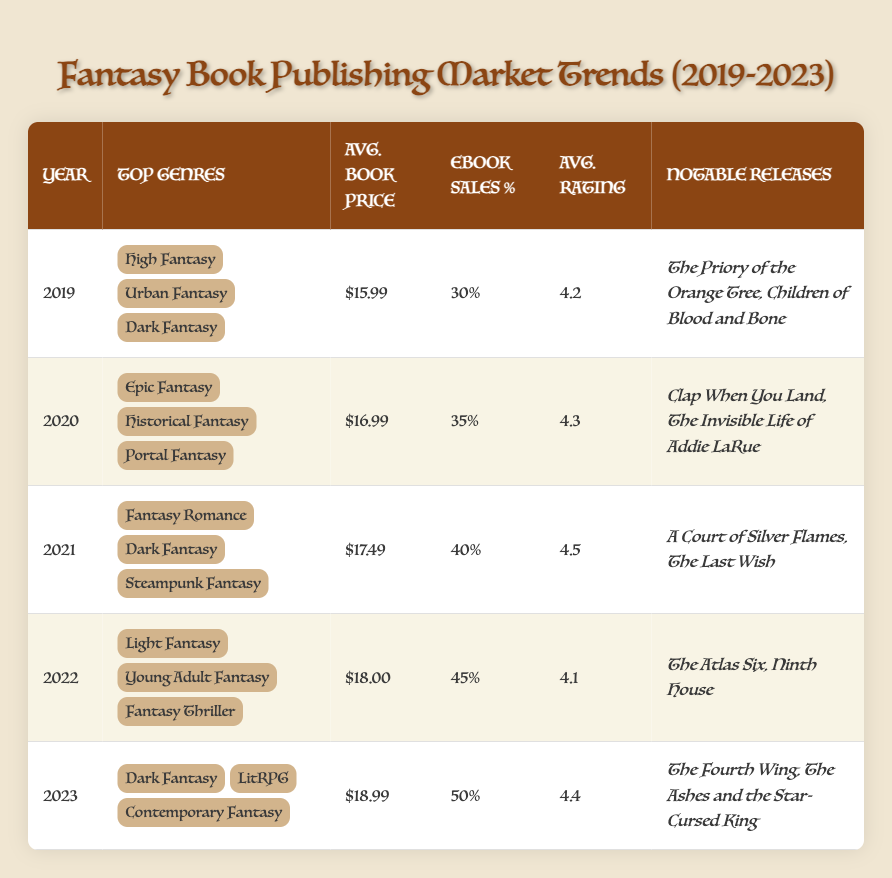What were the top genres in 2021? The table lists three top genres for each year. In 2021, the top genres are Fantasy Romance, Dark Fantasy, and Steampunk Fantasy as found in the relevant row for that year.
Answer: Fantasy Romance, Dark Fantasy, Steampunk Fantasy What was the average book price in 2023? The average book price for each year is shown in the column for average book price. For 2023, it is listed as $18.99.
Answer: $18.99 How many years had eBook sales percentage above 40%? To find this, count the years where the eBook sales percentage is more than 40%. In the table, that applies to 2021 (40%), 2022 (45%), and 2023 (50%), which provides a total of three years.
Answer: 3 What is the average rating of books released in 2020 and 2023 combined? To find the average rating for 2020 and 2023, we first identify their ratings: 2020 has an average rating of 4.3 and 2023 has a rating of 4.4. We then sum these ratings (4.3 + 4.4 = 8.7) and divide by 2 (8.7 / 2 = 4.35).
Answer: 4.35 Was there a year when the top genre was exclusively "Dark Fantasy"? Looking at the table, Dark Fantasy appears in multiple years but never exclusively as the only top genre. Therefore, the answer is no.
Answer: No What was the trend in average book prices from 2019 to 2023? Analyzing the average book prices from the table: 2019 ($15.99), 2020 ($16.99), 2021 ($17.49), 2022 ($18.00), and 2023 ($18.99), we see a steady increase each year, indicating a clear upward trend in prices over the five years.
Answer: Upward trend How many notable releases were noted in the year 2022? The notable releases for 2022 are listed as The Atlas Six and Ninth House. There are two notable releases for that year.
Answer: 2 In which year did "eBook sales percentage" first exceed 40%? Looking through the table, the first occurrence where eBook sales percentage exceeds 40% is in 2021, where it reaches 40%. The percentage for 2021 is therefore the critical point for this trend.
Answer: 2021 Which year had the highest average rating, and what was it? By examining the average rating column, 2021 has the highest rating at 4.5. This is the only rating above 4.5 across all years listed.
Answer: 2021, 4.5 